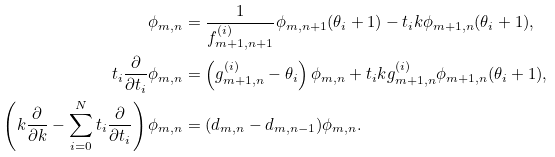Convert formula to latex. <formula><loc_0><loc_0><loc_500><loc_500>\phi _ { m , n } & = \frac { 1 } { f _ { m + 1 , n + 1 } ^ { ( i ) } } \phi _ { m , n + 1 } ( \theta _ { i } + 1 ) - t _ { i } k \phi _ { m + 1 , n } ( \theta _ { i } + 1 ) , \\ t _ { i } \frac { \partial } { \partial t _ { i } } \phi _ { m , n } & = \left ( g _ { m + 1 , n } ^ { ( i ) } - \theta _ { i } \right ) \phi _ { m , n } + t _ { i } k g _ { m + 1 , n } ^ { ( i ) } \phi _ { m + 1 , n } ( \theta _ { i } + 1 ) , \\ \left ( k \frac { \partial } { \partial k } - \sum _ { i = 0 } ^ { N } t _ { i } \frac { \partial } { \partial t _ { i } } \right ) \phi _ { m , n } & = ( d _ { m , n } - d _ { m , n - 1 } ) \phi _ { m , n } .</formula> 